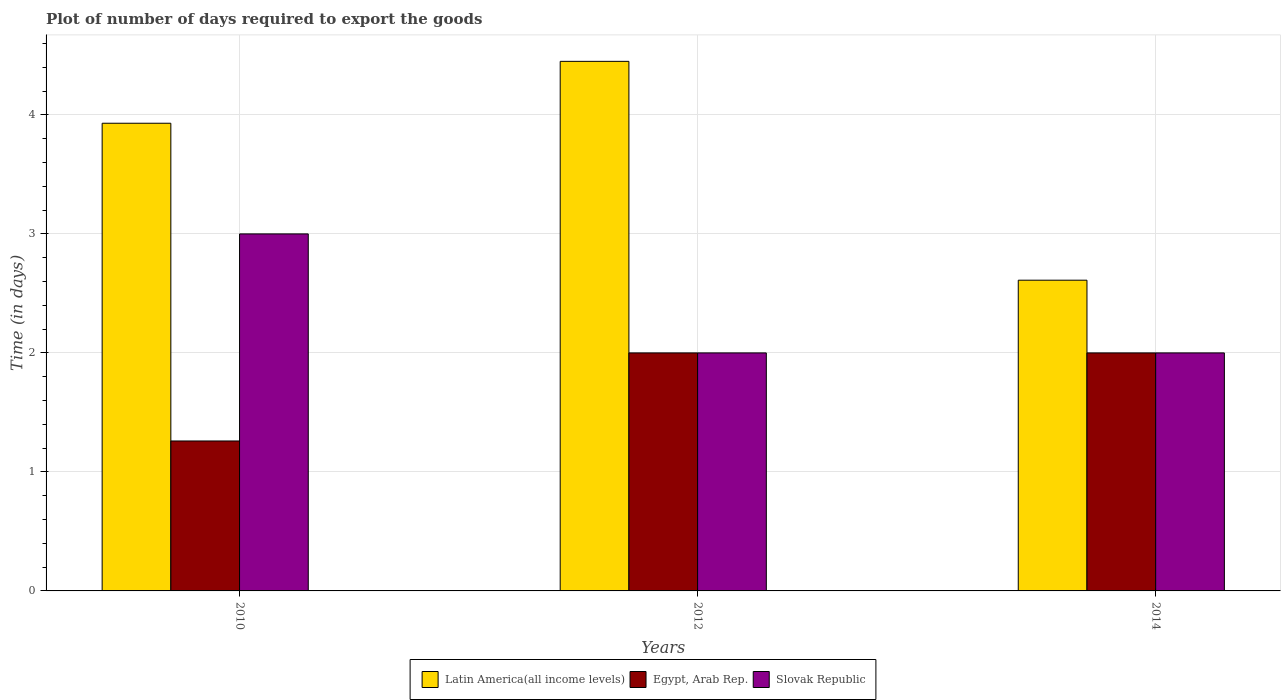How many different coloured bars are there?
Your answer should be very brief. 3. Are the number of bars on each tick of the X-axis equal?
Keep it short and to the point. Yes. How many bars are there on the 3rd tick from the left?
Provide a succinct answer. 3. How many bars are there on the 1st tick from the right?
Your answer should be compact. 3. In how many cases, is the number of bars for a given year not equal to the number of legend labels?
Provide a short and direct response. 0. Across all years, what is the maximum time required to export goods in Egypt, Arab Rep.?
Ensure brevity in your answer.  2. Across all years, what is the minimum time required to export goods in Egypt, Arab Rep.?
Offer a terse response. 1.26. In which year was the time required to export goods in Egypt, Arab Rep. maximum?
Offer a terse response. 2012. In which year was the time required to export goods in Egypt, Arab Rep. minimum?
Keep it short and to the point. 2010. What is the difference between the time required to export goods in Egypt, Arab Rep. in 2010 and that in 2014?
Give a very brief answer. -0.74. What is the difference between the time required to export goods in Slovak Republic in 2010 and the time required to export goods in Egypt, Arab Rep. in 2014?
Offer a very short reply. 1. What is the average time required to export goods in Latin America(all income levels) per year?
Your answer should be compact. 3.66. In the year 2010, what is the difference between the time required to export goods in Slovak Republic and time required to export goods in Latin America(all income levels)?
Give a very brief answer. -0.93. What is the ratio of the time required to export goods in Egypt, Arab Rep. in 2010 to that in 2014?
Your response must be concise. 0.63. What is the difference between the highest and the second highest time required to export goods in Latin America(all income levels)?
Keep it short and to the point. 0.52. What is the difference between the highest and the lowest time required to export goods in Latin America(all income levels)?
Provide a short and direct response. 1.84. What does the 2nd bar from the left in 2010 represents?
Provide a succinct answer. Egypt, Arab Rep. What does the 2nd bar from the right in 2014 represents?
Offer a very short reply. Egypt, Arab Rep. Are all the bars in the graph horizontal?
Provide a short and direct response. No. How many years are there in the graph?
Offer a very short reply. 3. What is the difference between two consecutive major ticks on the Y-axis?
Your answer should be very brief. 1. Does the graph contain any zero values?
Ensure brevity in your answer.  No. Does the graph contain grids?
Offer a very short reply. Yes. How many legend labels are there?
Your answer should be compact. 3. How are the legend labels stacked?
Ensure brevity in your answer.  Horizontal. What is the title of the graph?
Make the answer very short. Plot of number of days required to export the goods. Does "Sao Tome and Principe" appear as one of the legend labels in the graph?
Your answer should be very brief. No. What is the label or title of the Y-axis?
Your answer should be very brief. Time (in days). What is the Time (in days) of Latin America(all income levels) in 2010?
Ensure brevity in your answer.  3.93. What is the Time (in days) of Egypt, Arab Rep. in 2010?
Provide a short and direct response. 1.26. What is the Time (in days) in Latin America(all income levels) in 2012?
Give a very brief answer. 4.45. What is the Time (in days) of Latin America(all income levels) in 2014?
Give a very brief answer. 2.61. What is the Time (in days) in Egypt, Arab Rep. in 2014?
Give a very brief answer. 2. Across all years, what is the maximum Time (in days) in Latin America(all income levels)?
Ensure brevity in your answer.  4.45. Across all years, what is the maximum Time (in days) in Egypt, Arab Rep.?
Provide a short and direct response. 2. Across all years, what is the maximum Time (in days) in Slovak Republic?
Keep it short and to the point. 3. Across all years, what is the minimum Time (in days) of Latin America(all income levels)?
Provide a succinct answer. 2.61. Across all years, what is the minimum Time (in days) of Egypt, Arab Rep.?
Ensure brevity in your answer.  1.26. Across all years, what is the minimum Time (in days) in Slovak Republic?
Keep it short and to the point. 2. What is the total Time (in days) in Latin America(all income levels) in the graph?
Your answer should be very brief. 10.99. What is the total Time (in days) in Egypt, Arab Rep. in the graph?
Your response must be concise. 5.26. What is the total Time (in days) in Slovak Republic in the graph?
Make the answer very short. 7. What is the difference between the Time (in days) of Latin America(all income levels) in 2010 and that in 2012?
Provide a short and direct response. -0.52. What is the difference between the Time (in days) in Egypt, Arab Rep. in 2010 and that in 2012?
Make the answer very short. -0.74. What is the difference between the Time (in days) in Slovak Republic in 2010 and that in 2012?
Keep it short and to the point. 1. What is the difference between the Time (in days) of Latin America(all income levels) in 2010 and that in 2014?
Your answer should be very brief. 1.32. What is the difference between the Time (in days) of Egypt, Arab Rep. in 2010 and that in 2014?
Your answer should be compact. -0.74. What is the difference between the Time (in days) of Latin America(all income levels) in 2012 and that in 2014?
Keep it short and to the point. 1.84. What is the difference between the Time (in days) of Egypt, Arab Rep. in 2012 and that in 2014?
Keep it short and to the point. 0. What is the difference between the Time (in days) of Slovak Republic in 2012 and that in 2014?
Your answer should be compact. 0. What is the difference between the Time (in days) in Latin America(all income levels) in 2010 and the Time (in days) in Egypt, Arab Rep. in 2012?
Make the answer very short. 1.93. What is the difference between the Time (in days) in Latin America(all income levels) in 2010 and the Time (in days) in Slovak Republic in 2012?
Your answer should be very brief. 1.93. What is the difference between the Time (in days) in Egypt, Arab Rep. in 2010 and the Time (in days) in Slovak Republic in 2012?
Offer a very short reply. -0.74. What is the difference between the Time (in days) in Latin America(all income levels) in 2010 and the Time (in days) in Egypt, Arab Rep. in 2014?
Your response must be concise. 1.93. What is the difference between the Time (in days) in Latin America(all income levels) in 2010 and the Time (in days) in Slovak Republic in 2014?
Give a very brief answer. 1.93. What is the difference between the Time (in days) of Egypt, Arab Rep. in 2010 and the Time (in days) of Slovak Republic in 2014?
Offer a terse response. -0.74. What is the difference between the Time (in days) in Latin America(all income levels) in 2012 and the Time (in days) in Egypt, Arab Rep. in 2014?
Provide a short and direct response. 2.45. What is the difference between the Time (in days) in Latin America(all income levels) in 2012 and the Time (in days) in Slovak Republic in 2014?
Your answer should be compact. 2.45. What is the average Time (in days) of Latin America(all income levels) per year?
Ensure brevity in your answer.  3.66. What is the average Time (in days) in Egypt, Arab Rep. per year?
Make the answer very short. 1.75. What is the average Time (in days) of Slovak Republic per year?
Provide a short and direct response. 2.33. In the year 2010, what is the difference between the Time (in days) of Latin America(all income levels) and Time (in days) of Egypt, Arab Rep.?
Your answer should be compact. 2.67. In the year 2010, what is the difference between the Time (in days) of Egypt, Arab Rep. and Time (in days) of Slovak Republic?
Offer a terse response. -1.74. In the year 2012, what is the difference between the Time (in days) of Latin America(all income levels) and Time (in days) of Egypt, Arab Rep.?
Provide a succinct answer. 2.45. In the year 2012, what is the difference between the Time (in days) of Latin America(all income levels) and Time (in days) of Slovak Republic?
Your answer should be compact. 2.45. In the year 2012, what is the difference between the Time (in days) in Egypt, Arab Rep. and Time (in days) in Slovak Republic?
Make the answer very short. 0. In the year 2014, what is the difference between the Time (in days) of Latin America(all income levels) and Time (in days) of Egypt, Arab Rep.?
Keep it short and to the point. 0.61. In the year 2014, what is the difference between the Time (in days) in Latin America(all income levels) and Time (in days) in Slovak Republic?
Ensure brevity in your answer.  0.61. In the year 2014, what is the difference between the Time (in days) in Egypt, Arab Rep. and Time (in days) in Slovak Republic?
Provide a succinct answer. 0. What is the ratio of the Time (in days) of Latin America(all income levels) in 2010 to that in 2012?
Your answer should be compact. 0.88. What is the ratio of the Time (in days) in Egypt, Arab Rep. in 2010 to that in 2012?
Give a very brief answer. 0.63. What is the ratio of the Time (in days) of Slovak Republic in 2010 to that in 2012?
Make the answer very short. 1.5. What is the ratio of the Time (in days) in Latin America(all income levels) in 2010 to that in 2014?
Your response must be concise. 1.51. What is the ratio of the Time (in days) of Egypt, Arab Rep. in 2010 to that in 2014?
Ensure brevity in your answer.  0.63. What is the ratio of the Time (in days) of Slovak Republic in 2010 to that in 2014?
Give a very brief answer. 1.5. What is the ratio of the Time (in days) in Latin America(all income levels) in 2012 to that in 2014?
Ensure brevity in your answer.  1.7. What is the ratio of the Time (in days) in Slovak Republic in 2012 to that in 2014?
Ensure brevity in your answer.  1. What is the difference between the highest and the second highest Time (in days) of Latin America(all income levels)?
Ensure brevity in your answer.  0.52. What is the difference between the highest and the second highest Time (in days) of Egypt, Arab Rep.?
Provide a short and direct response. 0. What is the difference between the highest and the lowest Time (in days) in Latin America(all income levels)?
Make the answer very short. 1.84. What is the difference between the highest and the lowest Time (in days) of Egypt, Arab Rep.?
Make the answer very short. 0.74. 